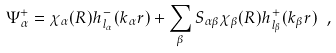Convert formula to latex. <formula><loc_0><loc_0><loc_500><loc_500>\Psi ^ { + } _ { \alpha } = \chi _ { \alpha } ( R ) h ^ { - } _ { l _ { \alpha } } ( k _ { \alpha } r ) + \sum _ { \beta } S _ { \alpha \beta } \chi _ { \beta } ( R ) h ^ { + } _ { l _ { \beta } } ( k _ { \beta } r ) \ ,</formula> 